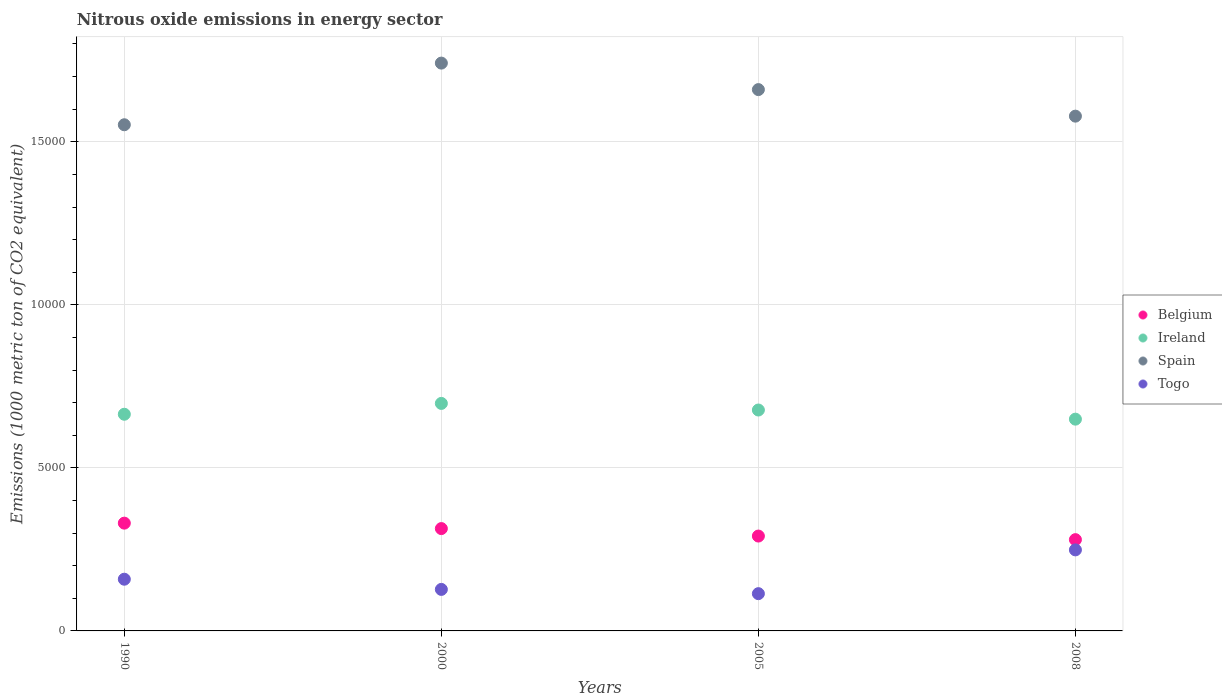How many different coloured dotlines are there?
Make the answer very short. 4. Is the number of dotlines equal to the number of legend labels?
Provide a succinct answer. Yes. What is the amount of nitrous oxide emitted in Togo in 1990?
Provide a short and direct response. 1585.7. Across all years, what is the maximum amount of nitrous oxide emitted in Togo?
Give a very brief answer. 2485.1. Across all years, what is the minimum amount of nitrous oxide emitted in Togo?
Give a very brief answer. 1142.8. In which year was the amount of nitrous oxide emitted in Ireland maximum?
Your answer should be compact. 2000. In which year was the amount of nitrous oxide emitted in Togo minimum?
Your answer should be very brief. 2005. What is the total amount of nitrous oxide emitted in Belgium in the graph?
Offer a terse response. 1.22e+04. What is the difference between the amount of nitrous oxide emitted in Ireland in 1990 and that in 2005?
Keep it short and to the point. -129.7. What is the difference between the amount of nitrous oxide emitted in Belgium in 2005 and the amount of nitrous oxide emitted in Ireland in 2008?
Provide a succinct answer. -3585. What is the average amount of nitrous oxide emitted in Togo per year?
Provide a short and direct response. 1621.72. In the year 2005, what is the difference between the amount of nitrous oxide emitted in Togo and amount of nitrous oxide emitted in Ireland?
Your answer should be very brief. -5631.7. What is the ratio of the amount of nitrous oxide emitted in Belgium in 1990 to that in 2000?
Ensure brevity in your answer.  1.05. Is the amount of nitrous oxide emitted in Belgium in 1990 less than that in 2008?
Offer a very short reply. No. What is the difference between the highest and the second highest amount of nitrous oxide emitted in Togo?
Offer a terse response. 899.4. What is the difference between the highest and the lowest amount of nitrous oxide emitted in Ireland?
Your answer should be very brief. 482.9. What is the difference between two consecutive major ticks on the Y-axis?
Provide a succinct answer. 5000. Does the graph contain grids?
Keep it short and to the point. Yes. Where does the legend appear in the graph?
Your answer should be compact. Center right. How are the legend labels stacked?
Keep it short and to the point. Vertical. What is the title of the graph?
Your answer should be very brief. Nitrous oxide emissions in energy sector. What is the label or title of the X-axis?
Provide a short and direct response. Years. What is the label or title of the Y-axis?
Provide a succinct answer. Emissions (1000 metric ton of CO2 equivalent). What is the Emissions (1000 metric ton of CO2 equivalent) in Belgium in 1990?
Ensure brevity in your answer.  3305.4. What is the Emissions (1000 metric ton of CO2 equivalent) in Ireland in 1990?
Offer a terse response. 6644.8. What is the Emissions (1000 metric ton of CO2 equivalent) of Spain in 1990?
Keep it short and to the point. 1.55e+04. What is the Emissions (1000 metric ton of CO2 equivalent) of Togo in 1990?
Keep it short and to the point. 1585.7. What is the Emissions (1000 metric ton of CO2 equivalent) of Belgium in 2000?
Your answer should be very brief. 3138.4. What is the Emissions (1000 metric ton of CO2 equivalent) of Ireland in 2000?
Your answer should be compact. 6977.3. What is the Emissions (1000 metric ton of CO2 equivalent) in Spain in 2000?
Give a very brief answer. 1.74e+04. What is the Emissions (1000 metric ton of CO2 equivalent) in Togo in 2000?
Provide a succinct answer. 1273.3. What is the Emissions (1000 metric ton of CO2 equivalent) of Belgium in 2005?
Ensure brevity in your answer.  2909.4. What is the Emissions (1000 metric ton of CO2 equivalent) of Ireland in 2005?
Your answer should be compact. 6774.5. What is the Emissions (1000 metric ton of CO2 equivalent) in Spain in 2005?
Ensure brevity in your answer.  1.66e+04. What is the Emissions (1000 metric ton of CO2 equivalent) in Togo in 2005?
Provide a succinct answer. 1142.8. What is the Emissions (1000 metric ton of CO2 equivalent) in Belgium in 2008?
Keep it short and to the point. 2799.3. What is the Emissions (1000 metric ton of CO2 equivalent) in Ireland in 2008?
Give a very brief answer. 6494.4. What is the Emissions (1000 metric ton of CO2 equivalent) of Spain in 2008?
Your response must be concise. 1.58e+04. What is the Emissions (1000 metric ton of CO2 equivalent) in Togo in 2008?
Keep it short and to the point. 2485.1. Across all years, what is the maximum Emissions (1000 metric ton of CO2 equivalent) in Belgium?
Offer a very short reply. 3305.4. Across all years, what is the maximum Emissions (1000 metric ton of CO2 equivalent) of Ireland?
Your answer should be very brief. 6977.3. Across all years, what is the maximum Emissions (1000 metric ton of CO2 equivalent) of Spain?
Your answer should be compact. 1.74e+04. Across all years, what is the maximum Emissions (1000 metric ton of CO2 equivalent) of Togo?
Provide a succinct answer. 2485.1. Across all years, what is the minimum Emissions (1000 metric ton of CO2 equivalent) of Belgium?
Keep it short and to the point. 2799.3. Across all years, what is the minimum Emissions (1000 metric ton of CO2 equivalent) in Ireland?
Provide a succinct answer. 6494.4. Across all years, what is the minimum Emissions (1000 metric ton of CO2 equivalent) in Spain?
Your answer should be very brief. 1.55e+04. Across all years, what is the minimum Emissions (1000 metric ton of CO2 equivalent) in Togo?
Provide a short and direct response. 1142.8. What is the total Emissions (1000 metric ton of CO2 equivalent) in Belgium in the graph?
Keep it short and to the point. 1.22e+04. What is the total Emissions (1000 metric ton of CO2 equivalent) in Ireland in the graph?
Your answer should be very brief. 2.69e+04. What is the total Emissions (1000 metric ton of CO2 equivalent) in Spain in the graph?
Your answer should be very brief. 6.53e+04. What is the total Emissions (1000 metric ton of CO2 equivalent) in Togo in the graph?
Your answer should be compact. 6486.9. What is the difference between the Emissions (1000 metric ton of CO2 equivalent) of Belgium in 1990 and that in 2000?
Your answer should be very brief. 167. What is the difference between the Emissions (1000 metric ton of CO2 equivalent) of Ireland in 1990 and that in 2000?
Ensure brevity in your answer.  -332.5. What is the difference between the Emissions (1000 metric ton of CO2 equivalent) of Spain in 1990 and that in 2000?
Your answer should be very brief. -1890.8. What is the difference between the Emissions (1000 metric ton of CO2 equivalent) in Togo in 1990 and that in 2000?
Offer a very short reply. 312.4. What is the difference between the Emissions (1000 metric ton of CO2 equivalent) of Belgium in 1990 and that in 2005?
Provide a succinct answer. 396. What is the difference between the Emissions (1000 metric ton of CO2 equivalent) in Ireland in 1990 and that in 2005?
Your answer should be very brief. -129.7. What is the difference between the Emissions (1000 metric ton of CO2 equivalent) of Spain in 1990 and that in 2005?
Provide a short and direct response. -1078.3. What is the difference between the Emissions (1000 metric ton of CO2 equivalent) in Togo in 1990 and that in 2005?
Keep it short and to the point. 442.9. What is the difference between the Emissions (1000 metric ton of CO2 equivalent) of Belgium in 1990 and that in 2008?
Keep it short and to the point. 506.1. What is the difference between the Emissions (1000 metric ton of CO2 equivalent) of Ireland in 1990 and that in 2008?
Your answer should be compact. 150.4. What is the difference between the Emissions (1000 metric ton of CO2 equivalent) of Spain in 1990 and that in 2008?
Give a very brief answer. -264.1. What is the difference between the Emissions (1000 metric ton of CO2 equivalent) of Togo in 1990 and that in 2008?
Your answer should be compact. -899.4. What is the difference between the Emissions (1000 metric ton of CO2 equivalent) of Belgium in 2000 and that in 2005?
Make the answer very short. 229. What is the difference between the Emissions (1000 metric ton of CO2 equivalent) of Ireland in 2000 and that in 2005?
Offer a very short reply. 202.8. What is the difference between the Emissions (1000 metric ton of CO2 equivalent) in Spain in 2000 and that in 2005?
Offer a very short reply. 812.5. What is the difference between the Emissions (1000 metric ton of CO2 equivalent) of Togo in 2000 and that in 2005?
Keep it short and to the point. 130.5. What is the difference between the Emissions (1000 metric ton of CO2 equivalent) in Belgium in 2000 and that in 2008?
Offer a terse response. 339.1. What is the difference between the Emissions (1000 metric ton of CO2 equivalent) in Ireland in 2000 and that in 2008?
Provide a succinct answer. 482.9. What is the difference between the Emissions (1000 metric ton of CO2 equivalent) in Spain in 2000 and that in 2008?
Offer a terse response. 1626.7. What is the difference between the Emissions (1000 metric ton of CO2 equivalent) in Togo in 2000 and that in 2008?
Your answer should be compact. -1211.8. What is the difference between the Emissions (1000 metric ton of CO2 equivalent) in Belgium in 2005 and that in 2008?
Provide a short and direct response. 110.1. What is the difference between the Emissions (1000 metric ton of CO2 equivalent) in Ireland in 2005 and that in 2008?
Your answer should be compact. 280.1. What is the difference between the Emissions (1000 metric ton of CO2 equivalent) in Spain in 2005 and that in 2008?
Your answer should be very brief. 814.2. What is the difference between the Emissions (1000 metric ton of CO2 equivalent) in Togo in 2005 and that in 2008?
Make the answer very short. -1342.3. What is the difference between the Emissions (1000 metric ton of CO2 equivalent) in Belgium in 1990 and the Emissions (1000 metric ton of CO2 equivalent) in Ireland in 2000?
Your response must be concise. -3671.9. What is the difference between the Emissions (1000 metric ton of CO2 equivalent) in Belgium in 1990 and the Emissions (1000 metric ton of CO2 equivalent) in Spain in 2000?
Provide a short and direct response. -1.41e+04. What is the difference between the Emissions (1000 metric ton of CO2 equivalent) of Belgium in 1990 and the Emissions (1000 metric ton of CO2 equivalent) of Togo in 2000?
Provide a short and direct response. 2032.1. What is the difference between the Emissions (1000 metric ton of CO2 equivalent) in Ireland in 1990 and the Emissions (1000 metric ton of CO2 equivalent) in Spain in 2000?
Provide a succinct answer. -1.08e+04. What is the difference between the Emissions (1000 metric ton of CO2 equivalent) in Ireland in 1990 and the Emissions (1000 metric ton of CO2 equivalent) in Togo in 2000?
Provide a succinct answer. 5371.5. What is the difference between the Emissions (1000 metric ton of CO2 equivalent) of Spain in 1990 and the Emissions (1000 metric ton of CO2 equivalent) of Togo in 2000?
Make the answer very short. 1.42e+04. What is the difference between the Emissions (1000 metric ton of CO2 equivalent) in Belgium in 1990 and the Emissions (1000 metric ton of CO2 equivalent) in Ireland in 2005?
Offer a very short reply. -3469.1. What is the difference between the Emissions (1000 metric ton of CO2 equivalent) in Belgium in 1990 and the Emissions (1000 metric ton of CO2 equivalent) in Spain in 2005?
Ensure brevity in your answer.  -1.33e+04. What is the difference between the Emissions (1000 metric ton of CO2 equivalent) of Belgium in 1990 and the Emissions (1000 metric ton of CO2 equivalent) of Togo in 2005?
Make the answer very short. 2162.6. What is the difference between the Emissions (1000 metric ton of CO2 equivalent) in Ireland in 1990 and the Emissions (1000 metric ton of CO2 equivalent) in Spain in 2005?
Make the answer very short. -9956.5. What is the difference between the Emissions (1000 metric ton of CO2 equivalent) of Ireland in 1990 and the Emissions (1000 metric ton of CO2 equivalent) of Togo in 2005?
Provide a short and direct response. 5502. What is the difference between the Emissions (1000 metric ton of CO2 equivalent) of Spain in 1990 and the Emissions (1000 metric ton of CO2 equivalent) of Togo in 2005?
Ensure brevity in your answer.  1.44e+04. What is the difference between the Emissions (1000 metric ton of CO2 equivalent) in Belgium in 1990 and the Emissions (1000 metric ton of CO2 equivalent) in Ireland in 2008?
Provide a succinct answer. -3189. What is the difference between the Emissions (1000 metric ton of CO2 equivalent) of Belgium in 1990 and the Emissions (1000 metric ton of CO2 equivalent) of Spain in 2008?
Keep it short and to the point. -1.25e+04. What is the difference between the Emissions (1000 metric ton of CO2 equivalent) of Belgium in 1990 and the Emissions (1000 metric ton of CO2 equivalent) of Togo in 2008?
Keep it short and to the point. 820.3. What is the difference between the Emissions (1000 metric ton of CO2 equivalent) of Ireland in 1990 and the Emissions (1000 metric ton of CO2 equivalent) of Spain in 2008?
Keep it short and to the point. -9142.3. What is the difference between the Emissions (1000 metric ton of CO2 equivalent) in Ireland in 1990 and the Emissions (1000 metric ton of CO2 equivalent) in Togo in 2008?
Your response must be concise. 4159.7. What is the difference between the Emissions (1000 metric ton of CO2 equivalent) in Spain in 1990 and the Emissions (1000 metric ton of CO2 equivalent) in Togo in 2008?
Offer a terse response. 1.30e+04. What is the difference between the Emissions (1000 metric ton of CO2 equivalent) in Belgium in 2000 and the Emissions (1000 metric ton of CO2 equivalent) in Ireland in 2005?
Your answer should be very brief. -3636.1. What is the difference between the Emissions (1000 metric ton of CO2 equivalent) in Belgium in 2000 and the Emissions (1000 metric ton of CO2 equivalent) in Spain in 2005?
Offer a terse response. -1.35e+04. What is the difference between the Emissions (1000 metric ton of CO2 equivalent) in Belgium in 2000 and the Emissions (1000 metric ton of CO2 equivalent) in Togo in 2005?
Your answer should be compact. 1995.6. What is the difference between the Emissions (1000 metric ton of CO2 equivalent) of Ireland in 2000 and the Emissions (1000 metric ton of CO2 equivalent) of Spain in 2005?
Give a very brief answer. -9624. What is the difference between the Emissions (1000 metric ton of CO2 equivalent) in Ireland in 2000 and the Emissions (1000 metric ton of CO2 equivalent) in Togo in 2005?
Keep it short and to the point. 5834.5. What is the difference between the Emissions (1000 metric ton of CO2 equivalent) of Spain in 2000 and the Emissions (1000 metric ton of CO2 equivalent) of Togo in 2005?
Provide a succinct answer. 1.63e+04. What is the difference between the Emissions (1000 metric ton of CO2 equivalent) of Belgium in 2000 and the Emissions (1000 metric ton of CO2 equivalent) of Ireland in 2008?
Provide a short and direct response. -3356. What is the difference between the Emissions (1000 metric ton of CO2 equivalent) in Belgium in 2000 and the Emissions (1000 metric ton of CO2 equivalent) in Spain in 2008?
Offer a terse response. -1.26e+04. What is the difference between the Emissions (1000 metric ton of CO2 equivalent) in Belgium in 2000 and the Emissions (1000 metric ton of CO2 equivalent) in Togo in 2008?
Provide a succinct answer. 653.3. What is the difference between the Emissions (1000 metric ton of CO2 equivalent) of Ireland in 2000 and the Emissions (1000 metric ton of CO2 equivalent) of Spain in 2008?
Give a very brief answer. -8809.8. What is the difference between the Emissions (1000 metric ton of CO2 equivalent) in Ireland in 2000 and the Emissions (1000 metric ton of CO2 equivalent) in Togo in 2008?
Ensure brevity in your answer.  4492.2. What is the difference between the Emissions (1000 metric ton of CO2 equivalent) of Spain in 2000 and the Emissions (1000 metric ton of CO2 equivalent) of Togo in 2008?
Your response must be concise. 1.49e+04. What is the difference between the Emissions (1000 metric ton of CO2 equivalent) of Belgium in 2005 and the Emissions (1000 metric ton of CO2 equivalent) of Ireland in 2008?
Make the answer very short. -3585. What is the difference between the Emissions (1000 metric ton of CO2 equivalent) of Belgium in 2005 and the Emissions (1000 metric ton of CO2 equivalent) of Spain in 2008?
Give a very brief answer. -1.29e+04. What is the difference between the Emissions (1000 metric ton of CO2 equivalent) of Belgium in 2005 and the Emissions (1000 metric ton of CO2 equivalent) of Togo in 2008?
Provide a short and direct response. 424.3. What is the difference between the Emissions (1000 metric ton of CO2 equivalent) in Ireland in 2005 and the Emissions (1000 metric ton of CO2 equivalent) in Spain in 2008?
Provide a short and direct response. -9012.6. What is the difference between the Emissions (1000 metric ton of CO2 equivalent) in Ireland in 2005 and the Emissions (1000 metric ton of CO2 equivalent) in Togo in 2008?
Offer a terse response. 4289.4. What is the difference between the Emissions (1000 metric ton of CO2 equivalent) of Spain in 2005 and the Emissions (1000 metric ton of CO2 equivalent) of Togo in 2008?
Make the answer very short. 1.41e+04. What is the average Emissions (1000 metric ton of CO2 equivalent) of Belgium per year?
Provide a succinct answer. 3038.12. What is the average Emissions (1000 metric ton of CO2 equivalent) of Ireland per year?
Your response must be concise. 6722.75. What is the average Emissions (1000 metric ton of CO2 equivalent) in Spain per year?
Make the answer very short. 1.63e+04. What is the average Emissions (1000 metric ton of CO2 equivalent) in Togo per year?
Provide a short and direct response. 1621.72. In the year 1990, what is the difference between the Emissions (1000 metric ton of CO2 equivalent) in Belgium and Emissions (1000 metric ton of CO2 equivalent) in Ireland?
Offer a terse response. -3339.4. In the year 1990, what is the difference between the Emissions (1000 metric ton of CO2 equivalent) of Belgium and Emissions (1000 metric ton of CO2 equivalent) of Spain?
Provide a short and direct response. -1.22e+04. In the year 1990, what is the difference between the Emissions (1000 metric ton of CO2 equivalent) of Belgium and Emissions (1000 metric ton of CO2 equivalent) of Togo?
Your answer should be compact. 1719.7. In the year 1990, what is the difference between the Emissions (1000 metric ton of CO2 equivalent) in Ireland and Emissions (1000 metric ton of CO2 equivalent) in Spain?
Provide a succinct answer. -8878.2. In the year 1990, what is the difference between the Emissions (1000 metric ton of CO2 equivalent) in Ireland and Emissions (1000 metric ton of CO2 equivalent) in Togo?
Offer a very short reply. 5059.1. In the year 1990, what is the difference between the Emissions (1000 metric ton of CO2 equivalent) in Spain and Emissions (1000 metric ton of CO2 equivalent) in Togo?
Your answer should be compact. 1.39e+04. In the year 2000, what is the difference between the Emissions (1000 metric ton of CO2 equivalent) of Belgium and Emissions (1000 metric ton of CO2 equivalent) of Ireland?
Make the answer very short. -3838.9. In the year 2000, what is the difference between the Emissions (1000 metric ton of CO2 equivalent) in Belgium and Emissions (1000 metric ton of CO2 equivalent) in Spain?
Give a very brief answer. -1.43e+04. In the year 2000, what is the difference between the Emissions (1000 metric ton of CO2 equivalent) of Belgium and Emissions (1000 metric ton of CO2 equivalent) of Togo?
Offer a very short reply. 1865.1. In the year 2000, what is the difference between the Emissions (1000 metric ton of CO2 equivalent) in Ireland and Emissions (1000 metric ton of CO2 equivalent) in Spain?
Make the answer very short. -1.04e+04. In the year 2000, what is the difference between the Emissions (1000 metric ton of CO2 equivalent) of Ireland and Emissions (1000 metric ton of CO2 equivalent) of Togo?
Keep it short and to the point. 5704. In the year 2000, what is the difference between the Emissions (1000 metric ton of CO2 equivalent) of Spain and Emissions (1000 metric ton of CO2 equivalent) of Togo?
Offer a very short reply. 1.61e+04. In the year 2005, what is the difference between the Emissions (1000 metric ton of CO2 equivalent) in Belgium and Emissions (1000 metric ton of CO2 equivalent) in Ireland?
Provide a short and direct response. -3865.1. In the year 2005, what is the difference between the Emissions (1000 metric ton of CO2 equivalent) in Belgium and Emissions (1000 metric ton of CO2 equivalent) in Spain?
Provide a short and direct response. -1.37e+04. In the year 2005, what is the difference between the Emissions (1000 metric ton of CO2 equivalent) of Belgium and Emissions (1000 metric ton of CO2 equivalent) of Togo?
Offer a terse response. 1766.6. In the year 2005, what is the difference between the Emissions (1000 metric ton of CO2 equivalent) of Ireland and Emissions (1000 metric ton of CO2 equivalent) of Spain?
Provide a succinct answer. -9826.8. In the year 2005, what is the difference between the Emissions (1000 metric ton of CO2 equivalent) in Ireland and Emissions (1000 metric ton of CO2 equivalent) in Togo?
Offer a terse response. 5631.7. In the year 2005, what is the difference between the Emissions (1000 metric ton of CO2 equivalent) in Spain and Emissions (1000 metric ton of CO2 equivalent) in Togo?
Give a very brief answer. 1.55e+04. In the year 2008, what is the difference between the Emissions (1000 metric ton of CO2 equivalent) of Belgium and Emissions (1000 metric ton of CO2 equivalent) of Ireland?
Your answer should be compact. -3695.1. In the year 2008, what is the difference between the Emissions (1000 metric ton of CO2 equivalent) of Belgium and Emissions (1000 metric ton of CO2 equivalent) of Spain?
Your response must be concise. -1.30e+04. In the year 2008, what is the difference between the Emissions (1000 metric ton of CO2 equivalent) of Belgium and Emissions (1000 metric ton of CO2 equivalent) of Togo?
Give a very brief answer. 314.2. In the year 2008, what is the difference between the Emissions (1000 metric ton of CO2 equivalent) of Ireland and Emissions (1000 metric ton of CO2 equivalent) of Spain?
Provide a succinct answer. -9292.7. In the year 2008, what is the difference between the Emissions (1000 metric ton of CO2 equivalent) of Ireland and Emissions (1000 metric ton of CO2 equivalent) of Togo?
Make the answer very short. 4009.3. In the year 2008, what is the difference between the Emissions (1000 metric ton of CO2 equivalent) of Spain and Emissions (1000 metric ton of CO2 equivalent) of Togo?
Offer a very short reply. 1.33e+04. What is the ratio of the Emissions (1000 metric ton of CO2 equivalent) of Belgium in 1990 to that in 2000?
Ensure brevity in your answer.  1.05. What is the ratio of the Emissions (1000 metric ton of CO2 equivalent) of Ireland in 1990 to that in 2000?
Your answer should be very brief. 0.95. What is the ratio of the Emissions (1000 metric ton of CO2 equivalent) in Spain in 1990 to that in 2000?
Provide a short and direct response. 0.89. What is the ratio of the Emissions (1000 metric ton of CO2 equivalent) in Togo in 1990 to that in 2000?
Offer a very short reply. 1.25. What is the ratio of the Emissions (1000 metric ton of CO2 equivalent) of Belgium in 1990 to that in 2005?
Your answer should be compact. 1.14. What is the ratio of the Emissions (1000 metric ton of CO2 equivalent) in Ireland in 1990 to that in 2005?
Keep it short and to the point. 0.98. What is the ratio of the Emissions (1000 metric ton of CO2 equivalent) of Spain in 1990 to that in 2005?
Ensure brevity in your answer.  0.94. What is the ratio of the Emissions (1000 metric ton of CO2 equivalent) of Togo in 1990 to that in 2005?
Your answer should be compact. 1.39. What is the ratio of the Emissions (1000 metric ton of CO2 equivalent) in Belgium in 1990 to that in 2008?
Your response must be concise. 1.18. What is the ratio of the Emissions (1000 metric ton of CO2 equivalent) in Ireland in 1990 to that in 2008?
Your answer should be very brief. 1.02. What is the ratio of the Emissions (1000 metric ton of CO2 equivalent) in Spain in 1990 to that in 2008?
Keep it short and to the point. 0.98. What is the ratio of the Emissions (1000 metric ton of CO2 equivalent) of Togo in 1990 to that in 2008?
Your response must be concise. 0.64. What is the ratio of the Emissions (1000 metric ton of CO2 equivalent) of Belgium in 2000 to that in 2005?
Offer a very short reply. 1.08. What is the ratio of the Emissions (1000 metric ton of CO2 equivalent) of Ireland in 2000 to that in 2005?
Offer a terse response. 1.03. What is the ratio of the Emissions (1000 metric ton of CO2 equivalent) in Spain in 2000 to that in 2005?
Provide a succinct answer. 1.05. What is the ratio of the Emissions (1000 metric ton of CO2 equivalent) of Togo in 2000 to that in 2005?
Keep it short and to the point. 1.11. What is the ratio of the Emissions (1000 metric ton of CO2 equivalent) in Belgium in 2000 to that in 2008?
Offer a terse response. 1.12. What is the ratio of the Emissions (1000 metric ton of CO2 equivalent) of Ireland in 2000 to that in 2008?
Your answer should be very brief. 1.07. What is the ratio of the Emissions (1000 metric ton of CO2 equivalent) of Spain in 2000 to that in 2008?
Your response must be concise. 1.1. What is the ratio of the Emissions (1000 metric ton of CO2 equivalent) in Togo in 2000 to that in 2008?
Provide a succinct answer. 0.51. What is the ratio of the Emissions (1000 metric ton of CO2 equivalent) in Belgium in 2005 to that in 2008?
Make the answer very short. 1.04. What is the ratio of the Emissions (1000 metric ton of CO2 equivalent) in Ireland in 2005 to that in 2008?
Your answer should be very brief. 1.04. What is the ratio of the Emissions (1000 metric ton of CO2 equivalent) in Spain in 2005 to that in 2008?
Keep it short and to the point. 1.05. What is the ratio of the Emissions (1000 metric ton of CO2 equivalent) of Togo in 2005 to that in 2008?
Provide a succinct answer. 0.46. What is the difference between the highest and the second highest Emissions (1000 metric ton of CO2 equivalent) in Belgium?
Offer a very short reply. 167. What is the difference between the highest and the second highest Emissions (1000 metric ton of CO2 equivalent) in Ireland?
Provide a short and direct response. 202.8. What is the difference between the highest and the second highest Emissions (1000 metric ton of CO2 equivalent) in Spain?
Your answer should be very brief. 812.5. What is the difference between the highest and the second highest Emissions (1000 metric ton of CO2 equivalent) of Togo?
Give a very brief answer. 899.4. What is the difference between the highest and the lowest Emissions (1000 metric ton of CO2 equivalent) in Belgium?
Keep it short and to the point. 506.1. What is the difference between the highest and the lowest Emissions (1000 metric ton of CO2 equivalent) in Ireland?
Your answer should be compact. 482.9. What is the difference between the highest and the lowest Emissions (1000 metric ton of CO2 equivalent) of Spain?
Your answer should be very brief. 1890.8. What is the difference between the highest and the lowest Emissions (1000 metric ton of CO2 equivalent) in Togo?
Give a very brief answer. 1342.3. 